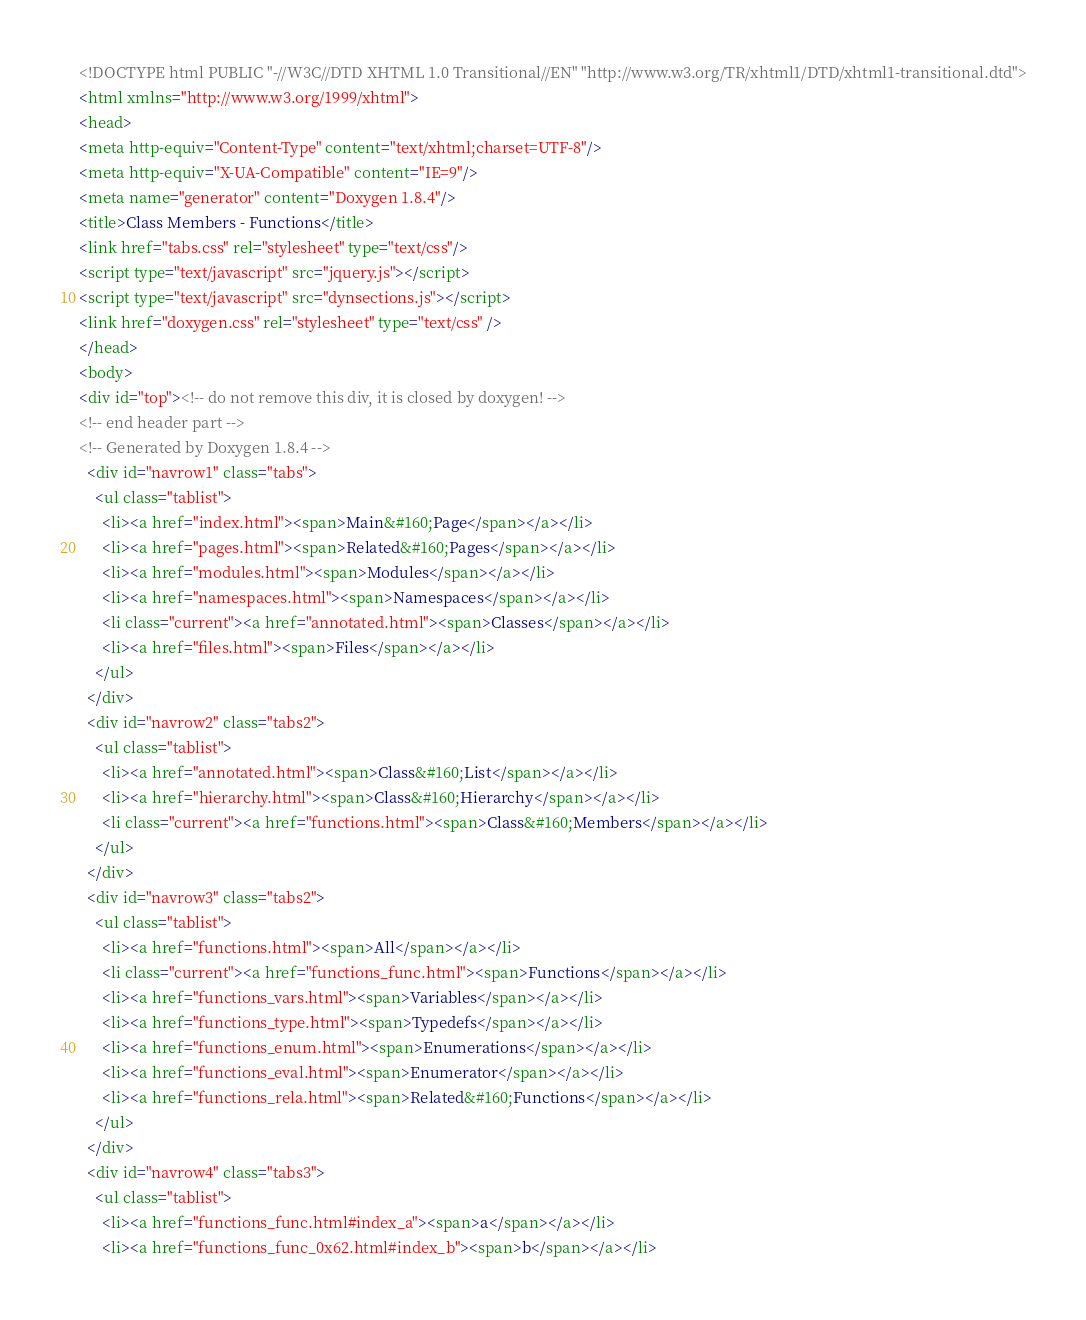Convert code to text. <code><loc_0><loc_0><loc_500><loc_500><_HTML_><!DOCTYPE html PUBLIC "-//W3C//DTD XHTML 1.0 Transitional//EN" "http://www.w3.org/TR/xhtml1/DTD/xhtml1-transitional.dtd">
<html xmlns="http://www.w3.org/1999/xhtml">
<head>
<meta http-equiv="Content-Type" content="text/xhtml;charset=UTF-8"/>
<meta http-equiv="X-UA-Compatible" content="IE=9"/>
<meta name="generator" content="Doxygen 1.8.4"/>
<title>Class Members - Functions</title>
<link href="tabs.css" rel="stylesheet" type="text/css"/>
<script type="text/javascript" src="jquery.js"></script>
<script type="text/javascript" src="dynsections.js"></script>
<link href="doxygen.css" rel="stylesheet" type="text/css" />
</head>
<body>
<div id="top"><!-- do not remove this div, it is closed by doxygen! -->
<!-- end header part -->
<!-- Generated by Doxygen 1.8.4 -->
  <div id="navrow1" class="tabs">
    <ul class="tablist">
      <li><a href="index.html"><span>Main&#160;Page</span></a></li>
      <li><a href="pages.html"><span>Related&#160;Pages</span></a></li>
      <li><a href="modules.html"><span>Modules</span></a></li>
      <li><a href="namespaces.html"><span>Namespaces</span></a></li>
      <li class="current"><a href="annotated.html"><span>Classes</span></a></li>
      <li><a href="files.html"><span>Files</span></a></li>
    </ul>
  </div>
  <div id="navrow2" class="tabs2">
    <ul class="tablist">
      <li><a href="annotated.html"><span>Class&#160;List</span></a></li>
      <li><a href="hierarchy.html"><span>Class&#160;Hierarchy</span></a></li>
      <li class="current"><a href="functions.html"><span>Class&#160;Members</span></a></li>
    </ul>
  </div>
  <div id="navrow3" class="tabs2">
    <ul class="tablist">
      <li><a href="functions.html"><span>All</span></a></li>
      <li class="current"><a href="functions_func.html"><span>Functions</span></a></li>
      <li><a href="functions_vars.html"><span>Variables</span></a></li>
      <li><a href="functions_type.html"><span>Typedefs</span></a></li>
      <li><a href="functions_enum.html"><span>Enumerations</span></a></li>
      <li><a href="functions_eval.html"><span>Enumerator</span></a></li>
      <li><a href="functions_rela.html"><span>Related&#160;Functions</span></a></li>
    </ul>
  </div>
  <div id="navrow4" class="tabs3">
    <ul class="tablist">
      <li><a href="functions_func.html#index_a"><span>a</span></a></li>
      <li><a href="functions_func_0x62.html#index_b"><span>b</span></a></li></code> 